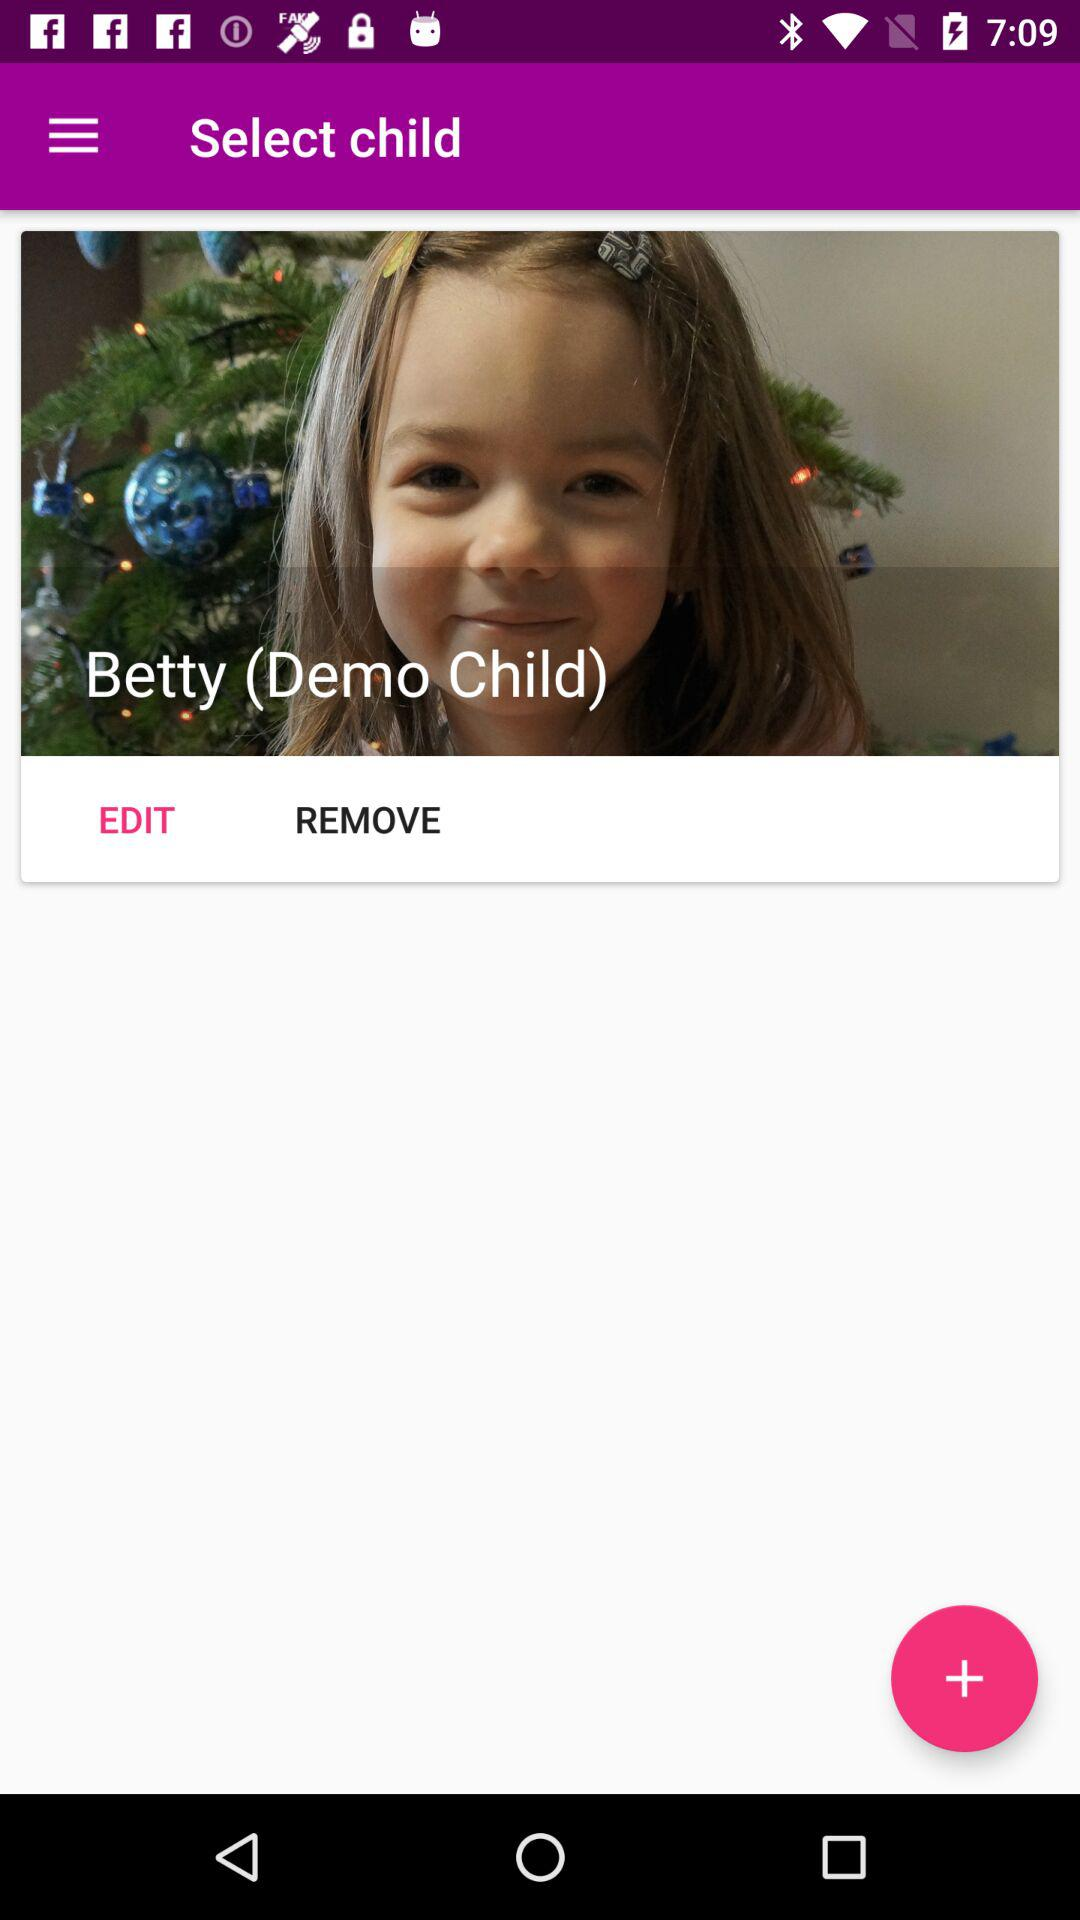What is the name of the child? The name of the child is Betty. 